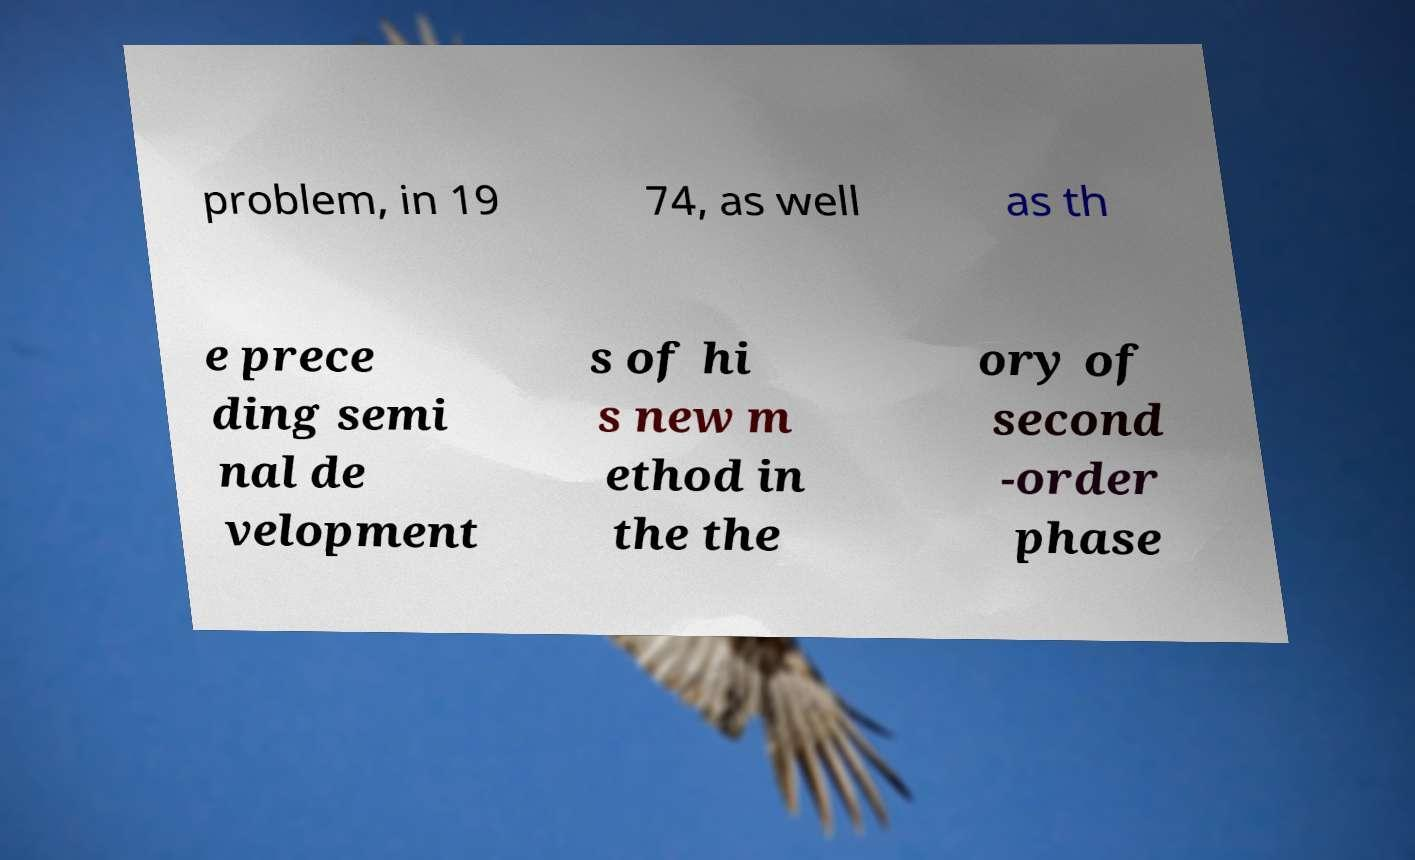Please read and relay the text visible in this image. What does it say? problem, in 19 74, as well as th e prece ding semi nal de velopment s of hi s new m ethod in the the ory of second -order phase 